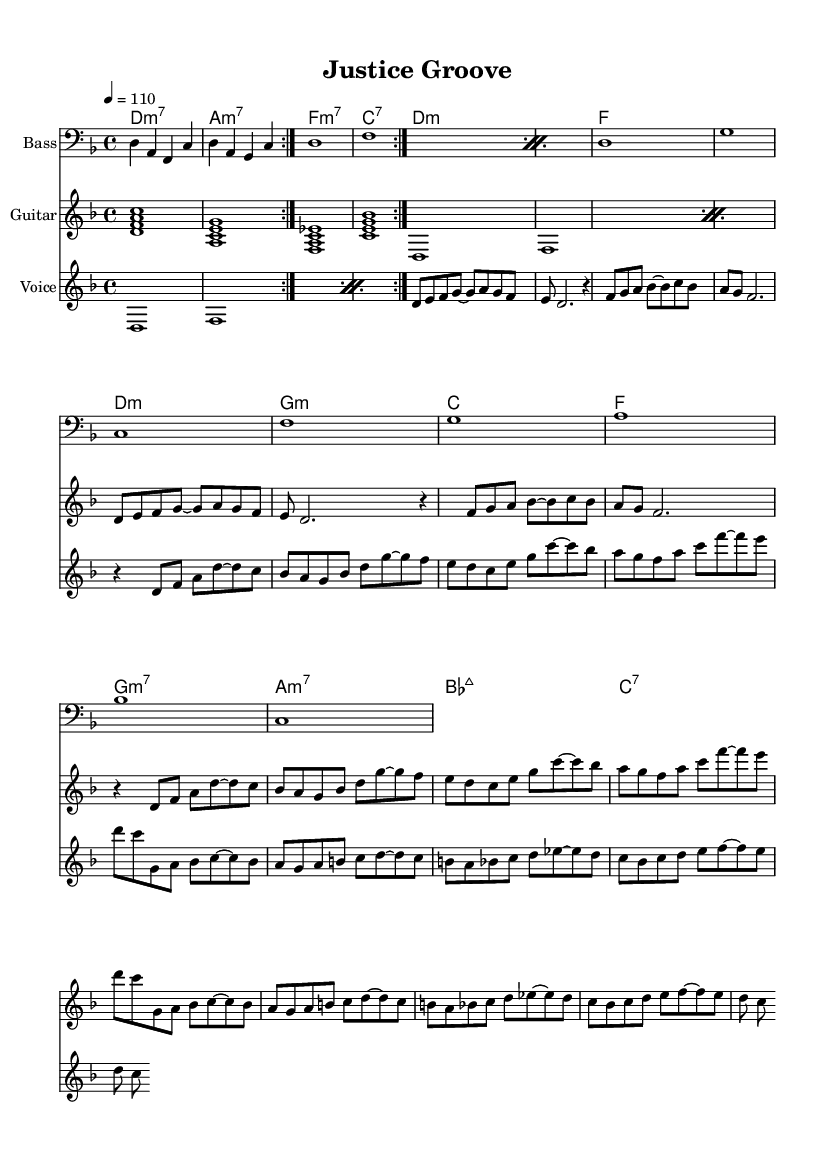What is the key signature of this music? The key signature is indicated by the sharp signs present on the staff. Here, the key is D minor, which contains one flat (B flat).
Answer: D minor What is the time signature of this music? The time signature appears at the beginning of the staff, which shows four beats in every measure, indicated by the "4/4".
Answer: 4/4 What is the tempo marking for this piece? The tempo marking reads "4 = 110", which indicates that there are 110 beats per minute.
Answer: 110 How many measures are in the verse section? The verse section has 4 measures, as indicated by the notation structure and the count of the bars present in that section.
Answer: 4 What is the main theme of the lyrics in the verse? The verse lyrics discuss fairness in justice and the issues with the current system, highlighting a sense of despair. This reflects the socially conscious theme of legal fairness.
Answer: Fairness in justice Which instruments are included in this piece? The score includes a bass, guitar, and voice, which are listed at the beginning of each staff section in the compiled score.
Answer: Bass, Guitar, Voice What is the chord progression used in the chorus? The chord progression starts with D minor, followed by G minor, C major, and includes some alterations. The first few chords are assessed through the chord names given in the score above the staff.
Answer: D minor, G minor, C major 